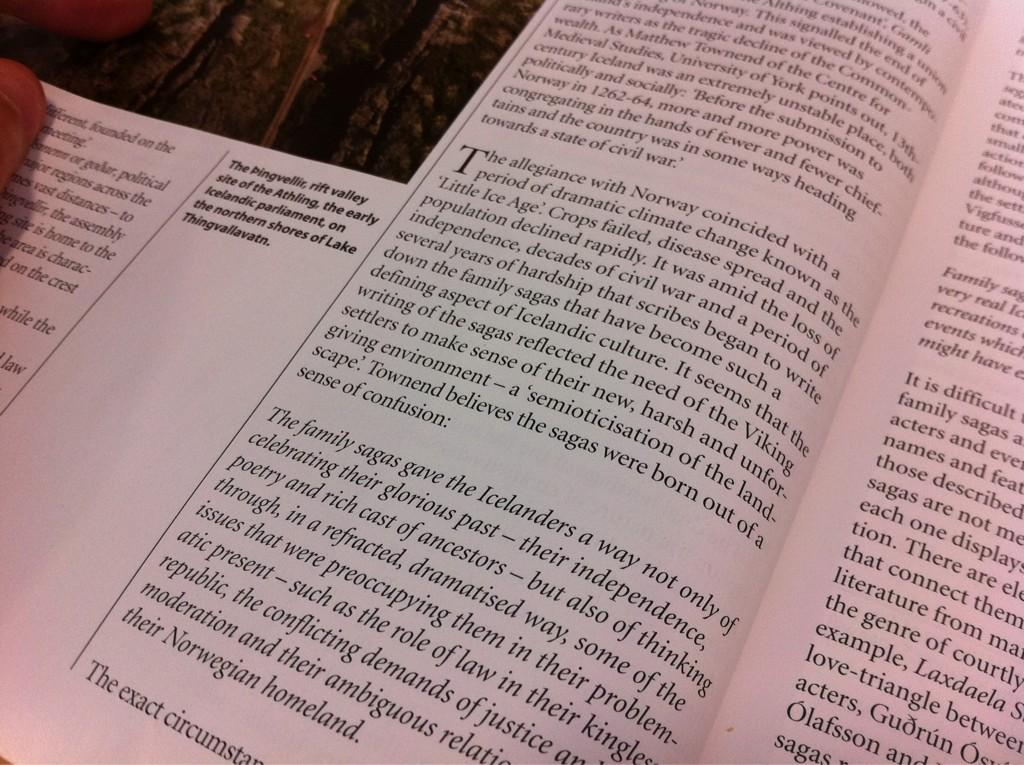<image>
Offer a succinct explanation of the picture presented. A book open to a wall of text including "The allegiance with Norway..." 